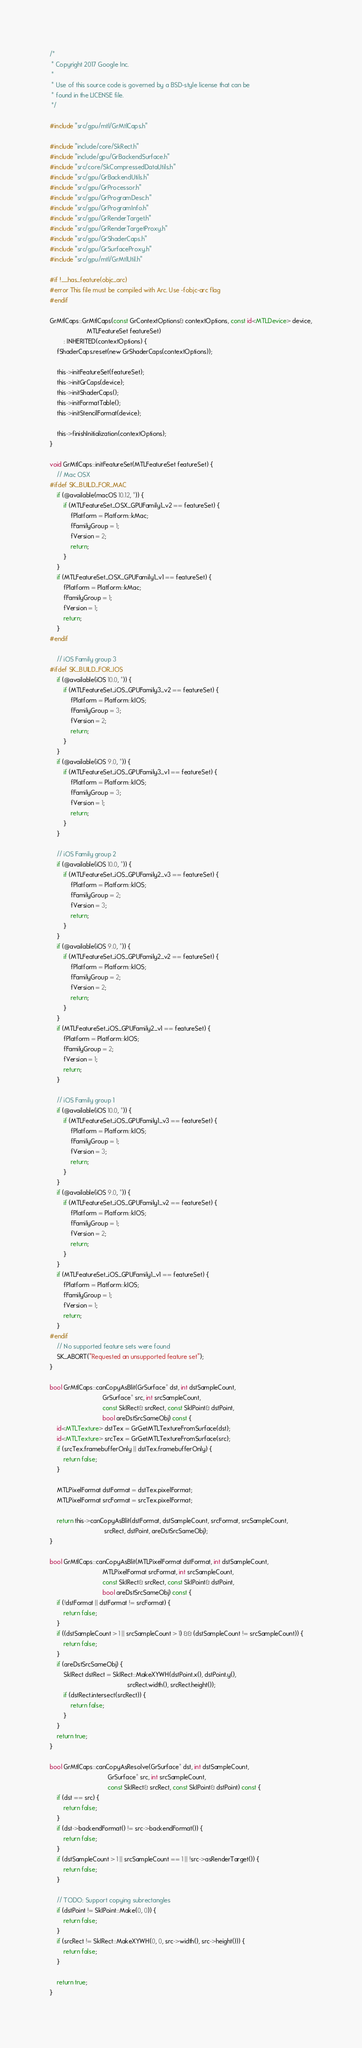Convert code to text. <code><loc_0><loc_0><loc_500><loc_500><_ObjectiveC_>/*
 * Copyright 2017 Google Inc.
 *
 * Use of this source code is governed by a BSD-style license that can be
 * found in the LICENSE file.
 */

#include "src/gpu/mtl/GrMtlCaps.h"

#include "include/core/SkRect.h"
#include "include/gpu/GrBackendSurface.h"
#include "src/core/SkCompressedDataUtils.h"
#include "src/gpu/GrBackendUtils.h"
#include "src/gpu/GrProcessor.h"
#include "src/gpu/GrProgramDesc.h"
#include "src/gpu/GrProgramInfo.h"
#include "src/gpu/GrRenderTarget.h"
#include "src/gpu/GrRenderTargetProxy.h"
#include "src/gpu/GrShaderCaps.h"
#include "src/gpu/GrSurfaceProxy.h"
#include "src/gpu/mtl/GrMtlUtil.h"

#if !__has_feature(objc_arc)
#error This file must be compiled with Arc. Use -fobjc-arc flag
#endif

GrMtlCaps::GrMtlCaps(const GrContextOptions& contextOptions, const id<MTLDevice> device,
                     MTLFeatureSet featureSet)
        : INHERITED(contextOptions) {
    fShaderCaps.reset(new GrShaderCaps(contextOptions));

    this->initFeatureSet(featureSet);
    this->initGrCaps(device);
    this->initShaderCaps();
    this->initFormatTable();
    this->initStencilFormat(device);

    this->finishInitialization(contextOptions);
}

void GrMtlCaps::initFeatureSet(MTLFeatureSet featureSet) {
    // Mac OSX
#ifdef SK_BUILD_FOR_MAC
    if (@available(macOS 10.12, *)) {
        if (MTLFeatureSet_OSX_GPUFamily1_v2 == featureSet) {
            fPlatform = Platform::kMac;
            fFamilyGroup = 1;
            fVersion = 2;
            return;
        }
    }
    if (MTLFeatureSet_OSX_GPUFamily1_v1 == featureSet) {
        fPlatform = Platform::kMac;
        fFamilyGroup = 1;
        fVersion = 1;
        return;
    }
#endif

    // iOS Family group 3
#ifdef SK_BUILD_FOR_IOS
    if (@available(iOS 10.0, *)) {
        if (MTLFeatureSet_iOS_GPUFamily3_v2 == featureSet) {
            fPlatform = Platform::kIOS;
            fFamilyGroup = 3;
            fVersion = 2;
            return;
        }
    }
    if (@available(iOS 9.0, *)) {
        if (MTLFeatureSet_iOS_GPUFamily3_v1 == featureSet) {
            fPlatform = Platform::kIOS;
            fFamilyGroup = 3;
            fVersion = 1;
            return;
        }
    }

    // iOS Family group 2
    if (@available(iOS 10.0, *)) {
        if (MTLFeatureSet_iOS_GPUFamily2_v3 == featureSet) {
            fPlatform = Platform::kIOS;
            fFamilyGroup = 2;
            fVersion = 3;
            return;
        }
    }
    if (@available(iOS 9.0, *)) {
        if (MTLFeatureSet_iOS_GPUFamily2_v2 == featureSet) {
            fPlatform = Platform::kIOS;
            fFamilyGroup = 2;
            fVersion = 2;
            return;
        }
    }
    if (MTLFeatureSet_iOS_GPUFamily2_v1 == featureSet) {
        fPlatform = Platform::kIOS;
        fFamilyGroup = 2;
        fVersion = 1;
        return;
    }

    // iOS Family group 1
    if (@available(iOS 10.0, *)) {
        if (MTLFeatureSet_iOS_GPUFamily1_v3 == featureSet) {
            fPlatform = Platform::kIOS;
            fFamilyGroup = 1;
            fVersion = 3;
            return;
        }
    }
    if (@available(iOS 9.0, *)) {
        if (MTLFeatureSet_iOS_GPUFamily1_v2 == featureSet) {
            fPlatform = Platform::kIOS;
            fFamilyGroup = 1;
            fVersion = 2;
            return;
        }
    }
    if (MTLFeatureSet_iOS_GPUFamily1_v1 == featureSet) {
        fPlatform = Platform::kIOS;
        fFamilyGroup = 1;
        fVersion = 1;
        return;
    }
#endif
    // No supported feature sets were found
    SK_ABORT("Requested an unsupported feature set");
}

bool GrMtlCaps::canCopyAsBlit(GrSurface* dst, int dstSampleCount,
                              GrSurface* src, int srcSampleCount,
                              const SkIRect& srcRect, const SkIPoint& dstPoint,
                              bool areDstSrcSameObj) const {
    id<MTLTexture> dstTex = GrGetMTLTextureFromSurface(dst);
    id<MTLTexture> srcTex = GrGetMTLTextureFromSurface(src);
    if (srcTex.framebufferOnly || dstTex.framebufferOnly) {
        return false;
    }

    MTLPixelFormat dstFormat = dstTex.pixelFormat;
    MTLPixelFormat srcFormat = srcTex.pixelFormat;

    return this->canCopyAsBlit(dstFormat, dstSampleCount, srcFormat, srcSampleCount,
                               srcRect, dstPoint, areDstSrcSameObj);
}

bool GrMtlCaps::canCopyAsBlit(MTLPixelFormat dstFormat, int dstSampleCount,
                              MTLPixelFormat srcFormat, int srcSampleCount,
                              const SkIRect& srcRect, const SkIPoint& dstPoint,
                              bool areDstSrcSameObj) const {
    if (!dstFormat || dstFormat != srcFormat) {
        return false;
    }
    if ((dstSampleCount > 1 || srcSampleCount > 1) && (dstSampleCount != srcSampleCount)) {
        return false;
    }
    if (areDstSrcSameObj) {
        SkIRect dstRect = SkIRect::MakeXYWH(dstPoint.x(), dstPoint.y(),
                                            srcRect.width(), srcRect.height());
        if (dstRect.intersect(srcRect)) {
            return false;
        }
    }
    return true;
}

bool GrMtlCaps::canCopyAsResolve(GrSurface* dst, int dstSampleCount,
                                 GrSurface* src, int srcSampleCount,
                                 const SkIRect& srcRect, const SkIPoint& dstPoint) const {
    if (dst == src) {
        return false;
    }
    if (dst->backendFormat() != src->backendFormat()) {
        return false;
    }
    if (dstSampleCount > 1 || srcSampleCount == 1 || !src->asRenderTarget()) {
        return false;
    }

    // TODO: Support copying subrectangles
    if (dstPoint != SkIPoint::Make(0, 0)) {
        return false;
    }
    if (srcRect != SkIRect::MakeXYWH(0, 0, src->width(), src->height())) {
        return false;
    }

    return true;
}
</code> 